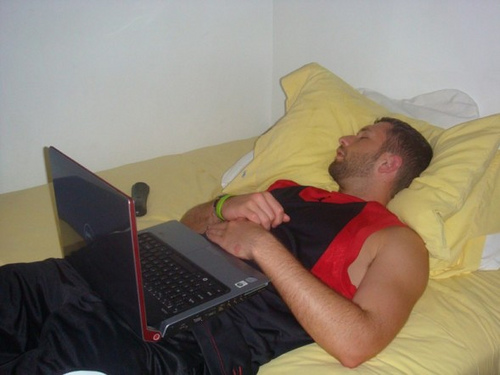Write a short, realistic scenario based on the image. Tom had just returned from an intense gym session. His muscles ached pleasantly as he sank into his bed. After setting up his laptop to browse some videos for relaxation, fatigue quickly overtook him. He didn’t even notice when his eyes closed and sleep enveloped him, the remote control he meant to use later forgotten beside him. 